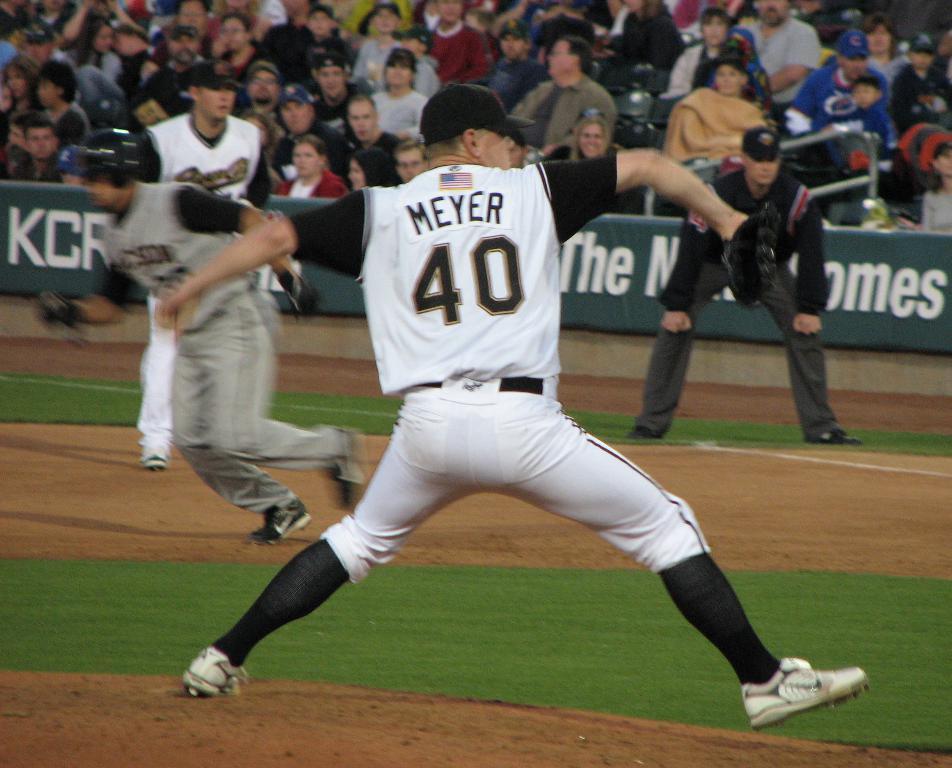Who is throwing the ball?
Provide a succinct answer. Meyer. What is his number?
Offer a very short reply. 40. 